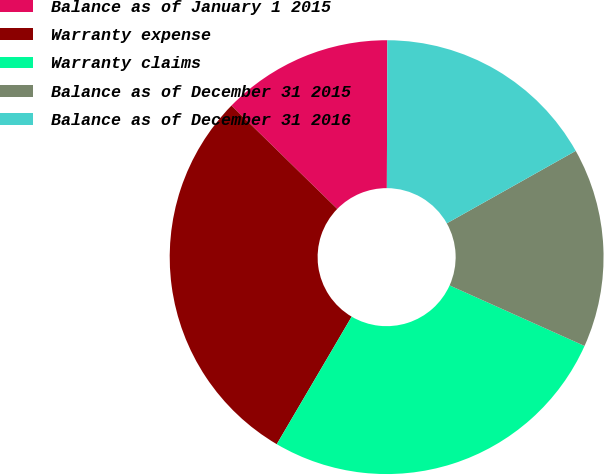Convert chart to OTSL. <chart><loc_0><loc_0><loc_500><loc_500><pie_chart><fcel>Balance as of January 1 2015<fcel>Warranty expense<fcel>Warranty claims<fcel>Balance as of December 31 2015<fcel>Balance as of December 31 2016<nl><fcel>12.74%<fcel>28.86%<fcel>26.74%<fcel>14.86%<fcel>16.8%<nl></chart> 